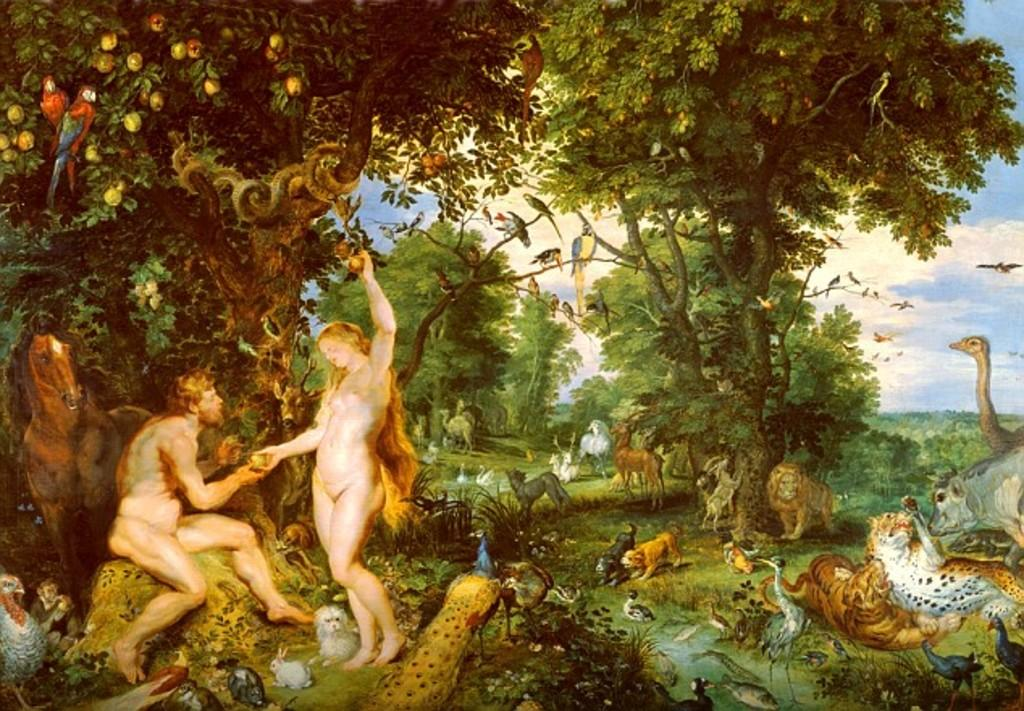What type of artwork is depicted in the image? The image is a painting. How many people are present in the painting? There are two persons in the painting. What animals can be seen in the painting? There is a horse, a lion, tigers, a rabbit, a peacock, and other animals in the painting. What type of vegetation is present in the painting? There are trees in the painting. What other creatures are in the painting? There are birds in the painting. What part of the natural environment is visible in the painting? The sky is visible in the painting. What type of music is being played by the coach in the painting? There is no coach present in the painting, and therefore no music can be heard. 